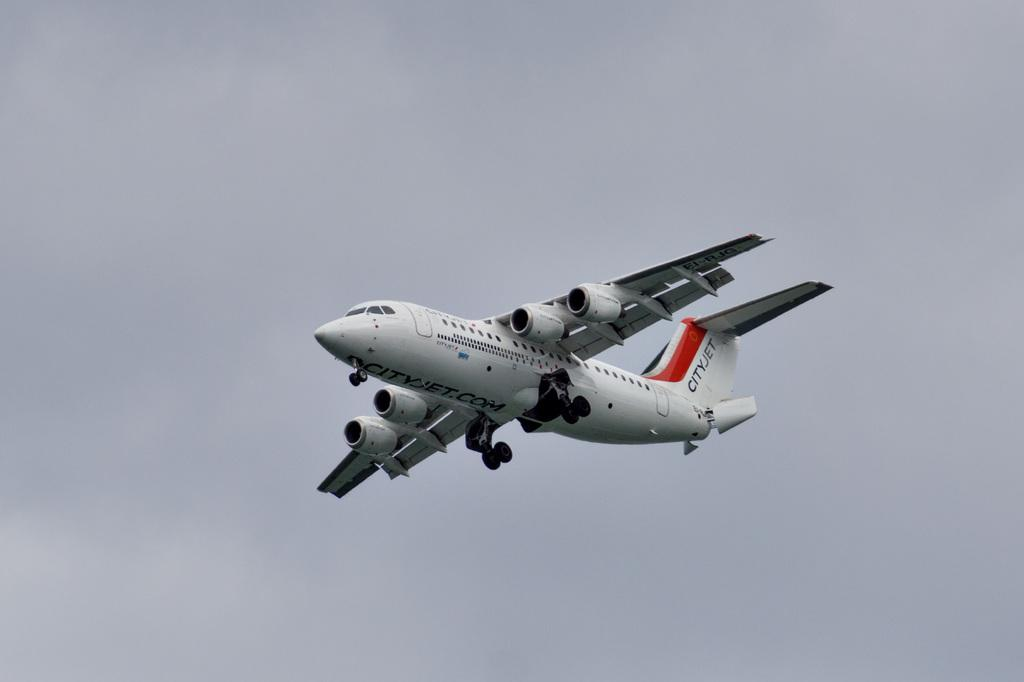What is the main subject of the picture? The main subject of the picture is an airplane. What is the airplane doing in the image? The airplane is flying in the air. What is the color of the airplane? The airplane is white in color. What can be seen in the background of the image? The sky is visible in the background of the image. How would you describe the sky in the image? The sky appears to be cloudy. Can you touch the deer in the image? There is no deer present in the image, so it cannot be touched. 